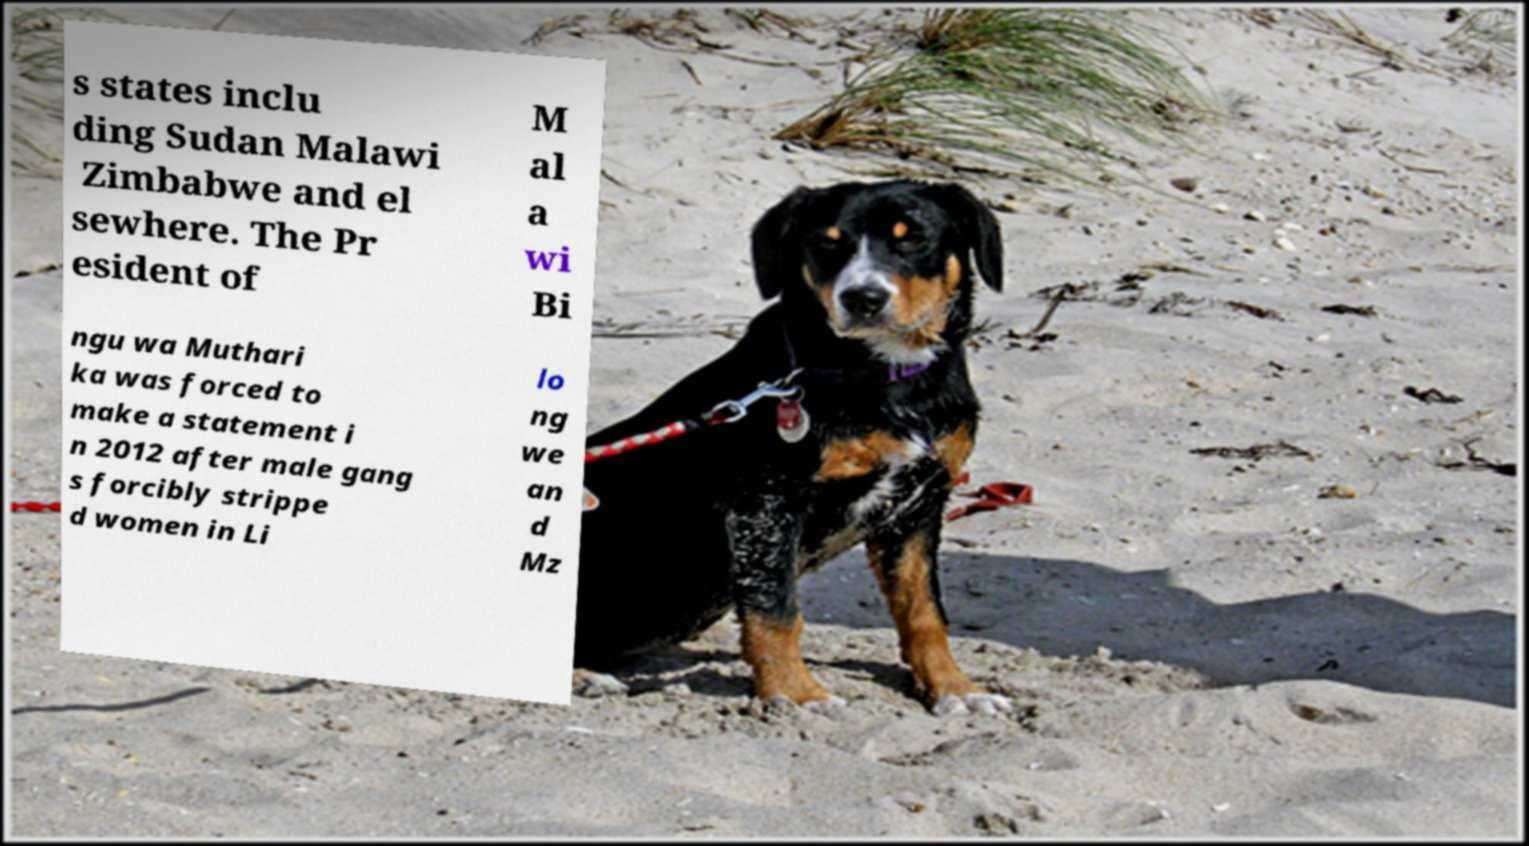Can you read and provide the text displayed in the image?This photo seems to have some interesting text. Can you extract and type it out for me? s states inclu ding Sudan Malawi Zimbabwe and el sewhere. The Pr esident of M al a wi Bi ngu wa Muthari ka was forced to make a statement i n 2012 after male gang s forcibly strippe d women in Li lo ng we an d Mz 